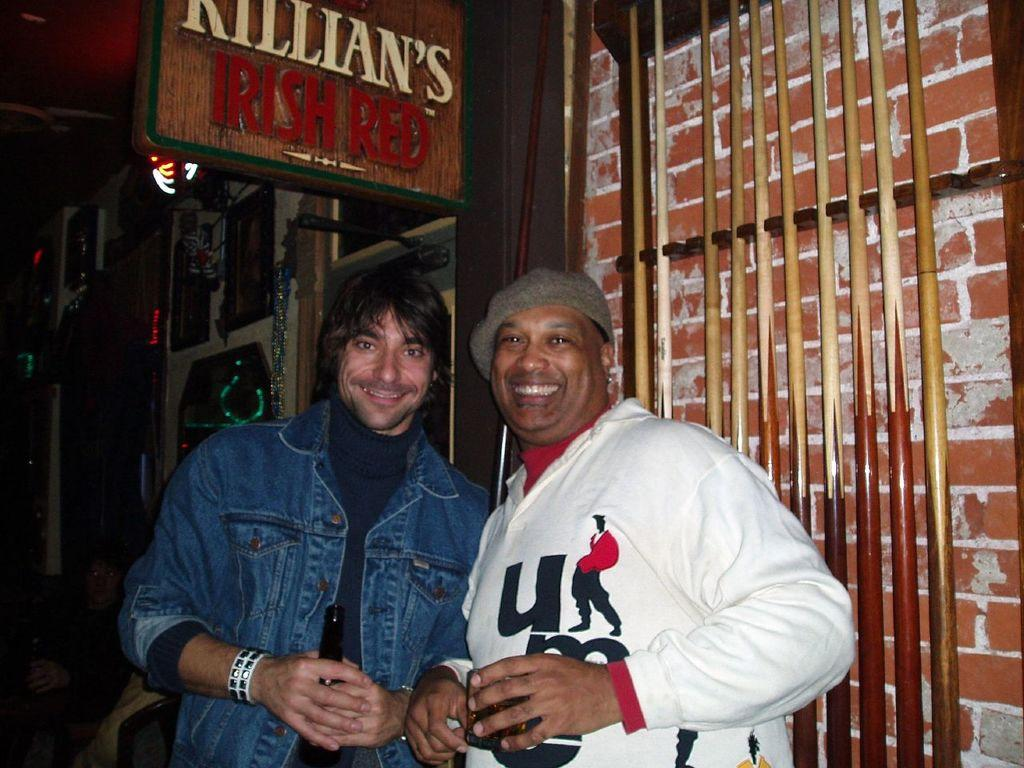<image>
Present a compact description of the photo's key features. The two men are smiling at the camera with a KILLIAN'S IRISH RED sign above. 